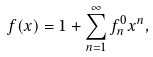Convert formula to latex. <formula><loc_0><loc_0><loc_500><loc_500>f ( x ) = 1 + \sum _ { n = 1 } ^ { \infty } f _ { n } ^ { 0 } x ^ { n } ,</formula> 